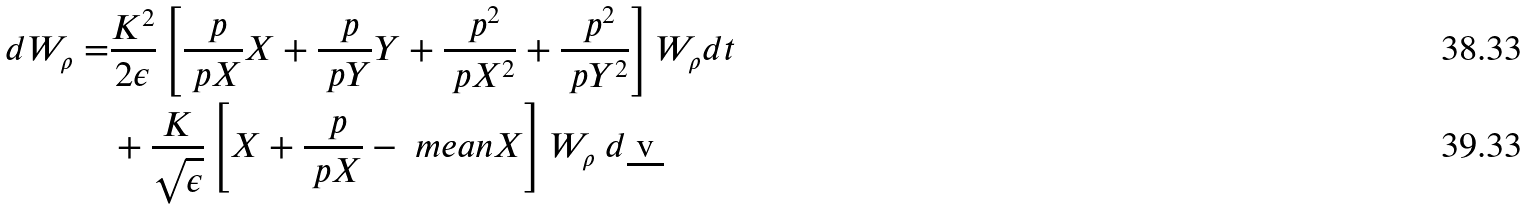<formula> <loc_0><loc_0><loc_500><loc_500>d W _ { \rho } = & \frac { K ^ { 2 } } { 2 \epsilon } \left [ \frac { \ p } { \ p X } X + \frac { \ p } { \ p Y } Y + \frac { \ p ^ { 2 } } { \ p X ^ { 2 } } + \frac { \ p ^ { 2 } } { \ p Y ^ { 2 } } \right ] W _ { \rho } d t \\ & + \frac { K } { \sqrt { \epsilon } } \left [ X + \frac { \ p } { \ p X } - \ m e a n { X } \right ] W _ { \rho } \ d \underbar { v }</formula> 